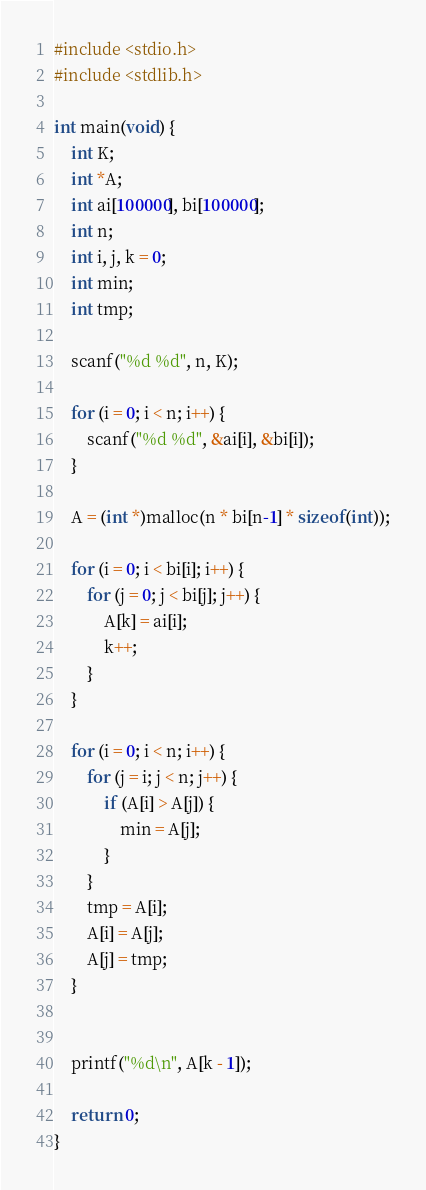<code> <loc_0><loc_0><loc_500><loc_500><_C_>#include <stdio.h>
#include <stdlib.h>

int main(void) {
	int K;
	int *A;
	int ai[100000], bi[100000];
	int n;
	int i, j, k = 0;
	int min;
	int tmp;
	
	scanf("%d %d", n, K);
	
	for (i = 0; i < n; i++) {
		scanf("%d %d", &ai[i], &bi[i]);
	}
	
	A = (int *)malloc(n * bi[n-1] * sizeof(int));

	for (i = 0; i < bi[i]; i++) {
		for (j = 0; j < bi[j]; j++) {
			A[k] = ai[i];
			k++;
		}
	}
	
	for (i = 0; i < n; i++) {
		for (j = i; j < n; j++) {
			if (A[i] > A[j]) {
				min = A[j];
			}
		}
		tmp = A[i];
		A[i] = A[j];
		A[j] = tmp;
	}
	
	
	printf("%d\n", A[k - 1]);

	return 0;
}
</code> 